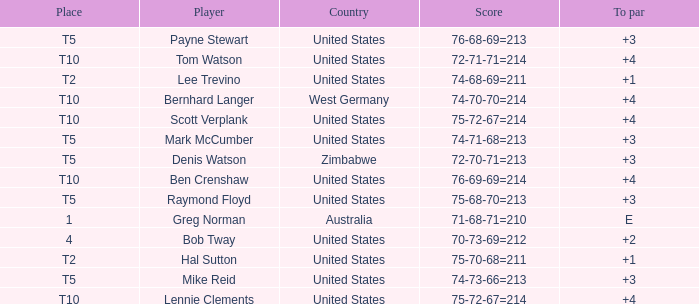What is player raymond floyd's country? United States. 